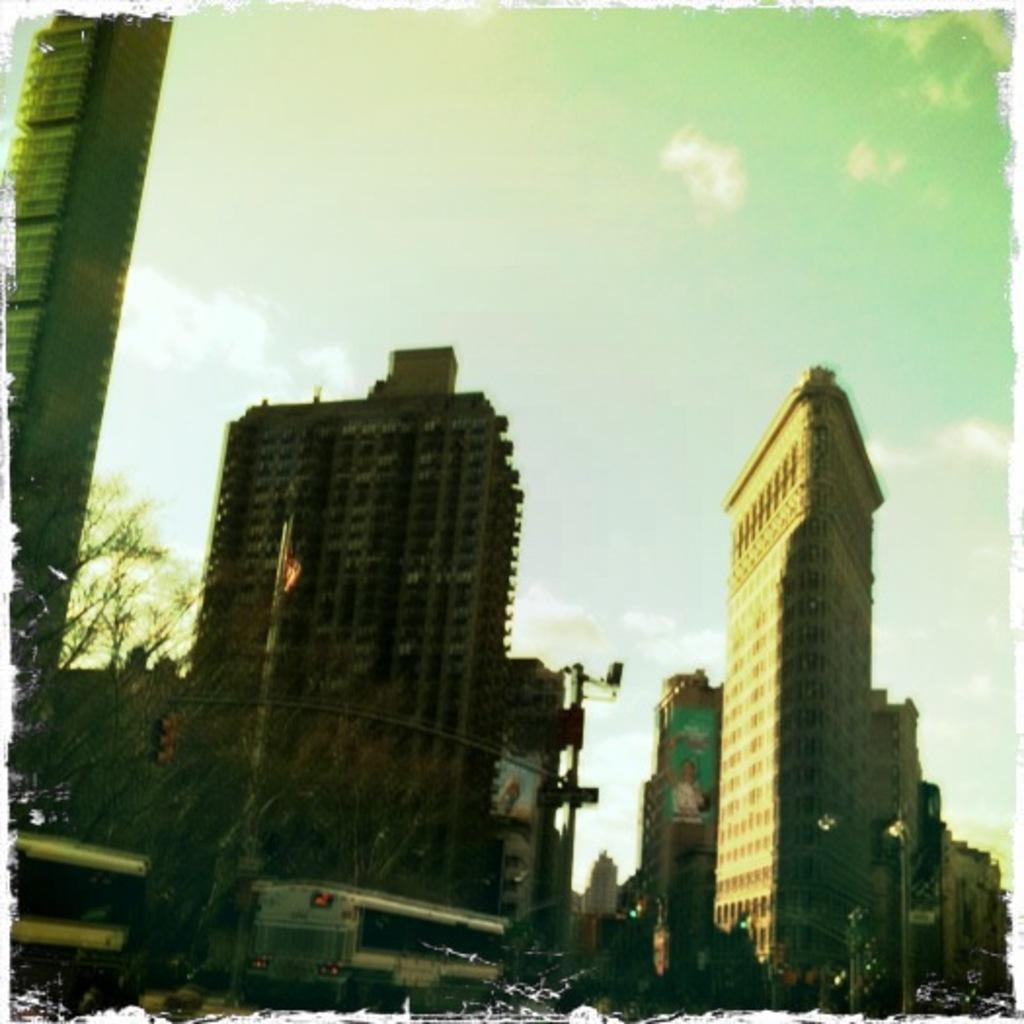How would you summarize this image in a sentence or two? In the picture I can see buildings, vehicles, poles and some other objects. In the background I can see the sky. 